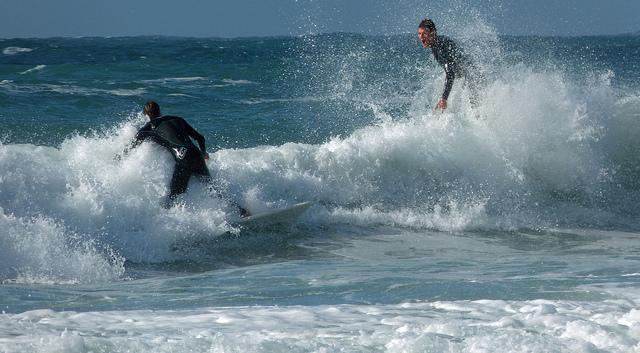How many people are there?
Give a very brief answer. 2. How many people are surfing?
Give a very brief answer. 2. How many drinks cups have straw?
Give a very brief answer. 0. 